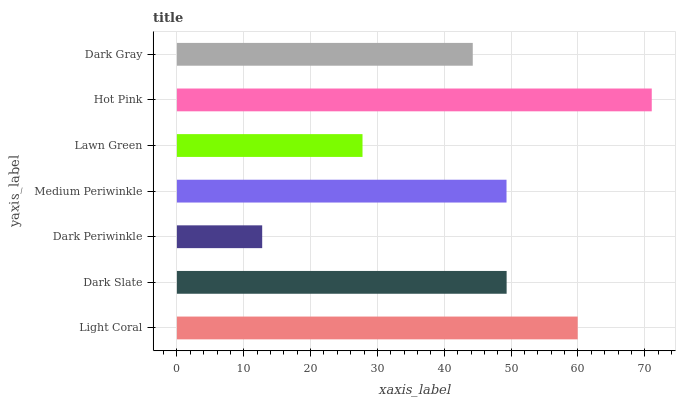Is Dark Periwinkle the minimum?
Answer yes or no. Yes. Is Hot Pink the maximum?
Answer yes or no. Yes. Is Dark Slate the minimum?
Answer yes or no. No. Is Dark Slate the maximum?
Answer yes or no. No. Is Light Coral greater than Dark Slate?
Answer yes or no. Yes. Is Dark Slate less than Light Coral?
Answer yes or no. Yes. Is Dark Slate greater than Light Coral?
Answer yes or no. No. Is Light Coral less than Dark Slate?
Answer yes or no. No. Is Medium Periwinkle the high median?
Answer yes or no. Yes. Is Medium Periwinkle the low median?
Answer yes or no. Yes. Is Hot Pink the high median?
Answer yes or no. No. Is Light Coral the low median?
Answer yes or no. No. 